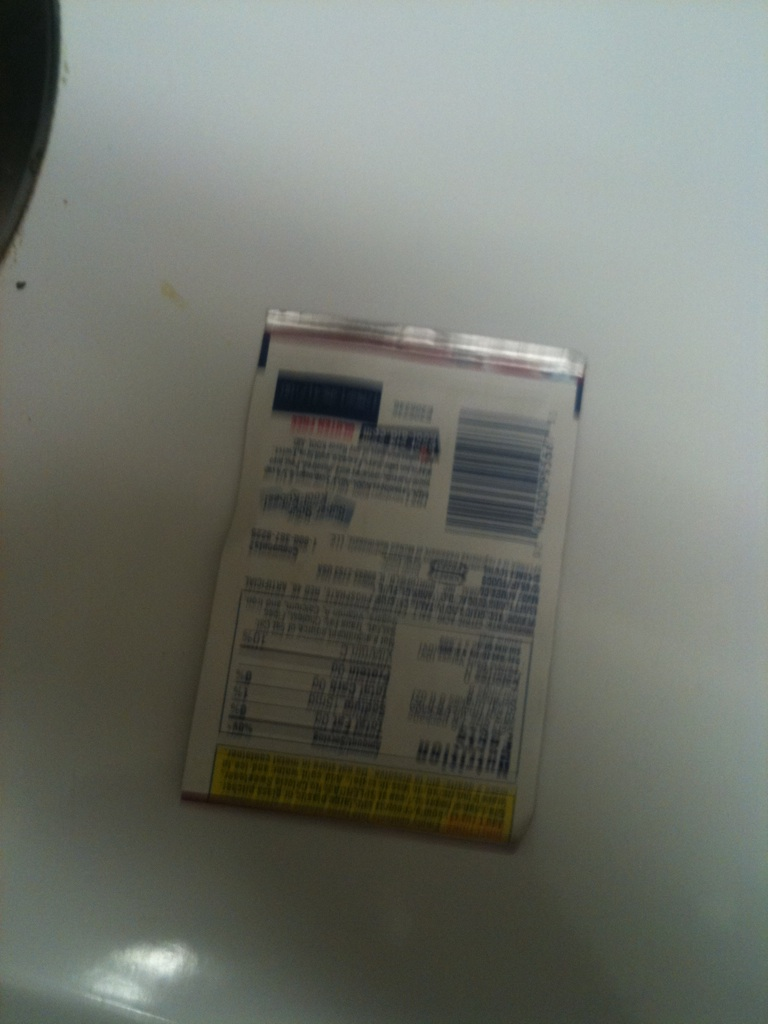How would this product be used in cooking? While the contents of this package aren't clear, such products are typically spices, seasonings, or other cooking essentials. Based on their appearance, they may be used to enhance flavors, preserve food, or contribute particular textures to dishes. Check the front side for exact usage instructions. 